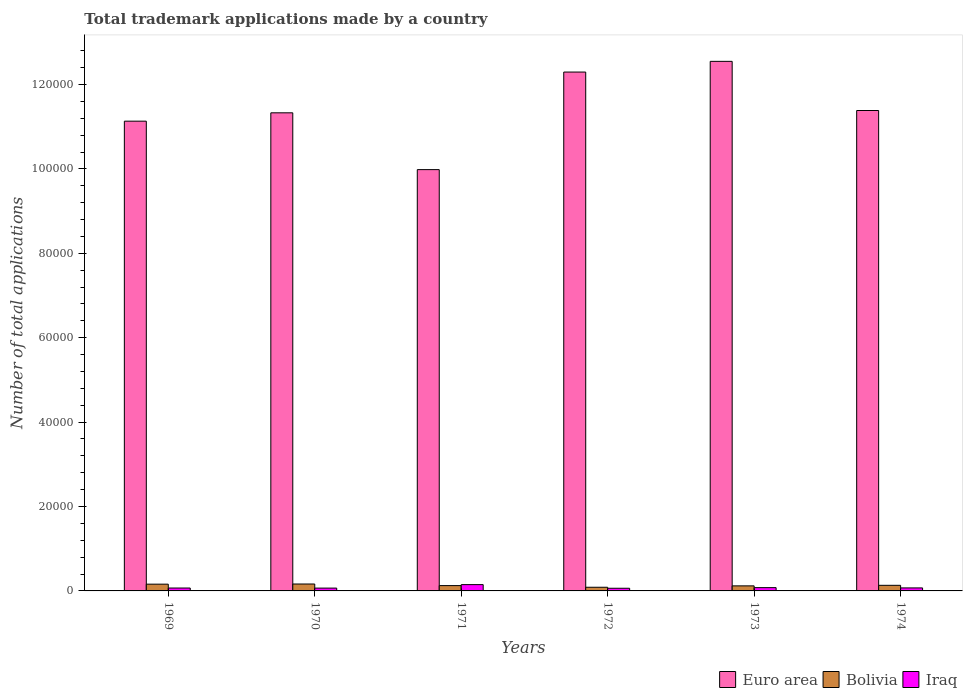How many bars are there on the 4th tick from the right?
Give a very brief answer. 3. What is the label of the 1st group of bars from the left?
Ensure brevity in your answer.  1969. What is the number of applications made by in Iraq in 1969?
Ensure brevity in your answer.  688. Across all years, what is the maximum number of applications made by in Bolivia?
Ensure brevity in your answer.  1640. Across all years, what is the minimum number of applications made by in Bolivia?
Your answer should be compact. 868. In which year was the number of applications made by in Euro area maximum?
Keep it short and to the point. 1973. What is the total number of applications made by in Iraq in the graph?
Provide a short and direct response. 4972. What is the difference between the number of applications made by in Iraq in 1972 and that in 1974?
Offer a very short reply. -84. What is the difference between the number of applications made by in Iraq in 1969 and the number of applications made by in Bolivia in 1973?
Give a very brief answer. -509. What is the average number of applications made by in Iraq per year?
Your answer should be compact. 828.67. In the year 1972, what is the difference between the number of applications made by in Euro area and number of applications made by in Bolivia?
Provide a short and direct response. 1.22e+05. What is the ratio of the number of applications made by in Bolivia in 1969 to that in 1973?
Offer a very short reply. 1.34. Is the number of applications made by in Bolivia in 1970 less than that in 1972?
Provide a succinct answer. No. Is the difference between the number of applications made by in Euro area in 1969 and 1974 greater than the difference between the number of applications made by in Bolivia in 1969 and 1974?
Make the answer very short. No. What is the difference between the highest and the second highest number of applications made by in Iraq?
Your answer should be very brief. 715. What is the difference between the highest and the lowest number of applications made by in Iraq?
Your answer should be very brief. 863. Is the sum of the number of applications made by in Bolivia in 1973 and 1974 greater than the maximum number of applications made by in Euro area across all years?
Your response must be concise. No. What does the 3rd bar from the left in 1970 represents?
Keep it short and to the point. Iraq. Are all the bars in the graph horizontal?
Provide a short and direct response. No. How many years are there in the graph?
Your answer should be very brief. 6. Are the values on the major ticks of Y-axis written in scientific E-notation?
Provide a short and direct response. No. Does the graph contain any zero values?
Provide a succinct answer. No. Where does the legend appear in the graph?
Provide a succinct answer. Bottom right. What is the title of the graph?
Give a very brief answer. Total trademark applications made by a country. Does "Croatia" appear as one of the legend labels in the graph?
Provide a short and direct response. No. What is the label or title of the X-axis?
Give a very brief answer. Years. What is the label or title of the Y-axis?
Make the answer very short. Number of total applications. What is the Number of total applications of Euro area in 1969?
Your answer should be very brief. 1.11e+05. What is the Number of total applications of Bolivia in 1969?
Provide a short and direct response. 1600. What is the Number of total applications in Iraq in 1969?
Your response must be concise. 688. What is the Number of total applications of Euro area in 1970?
Give a very brief answer. 1.13e+05. What is the Number of total applications in Bolivia in 1970?
Offer a very short reply. 1640. What is the Number of total applications in Iraq in 1970?
Offer a very short reply. 669. What is the Number of total applications of Euro area in 1971?
Your response must be concise. 9.98e+04. What is the Number of total applications of Bolivia in 1971?
Make the answer very short. 1261. What is the Number of total applications in Iraq in 1971?
Your answer should be very brief. 1493. What is the Number of total applications in Euro area in 1972?
Your answer should be very brief. 1.23e+05. What is the Number of total applications in Bolivia in 1972?
Ensure brevity in your answer.  868. What is the Number of total applications of Iraq in 1972?
Offer a terse response. 630. What is the Number of total applications in Euro area in 1973?
Give a very brief answer. 1.25e+05. What is the Number of total applications of Bolivia in 1973?
Your response must be concise. 1197. What is the Number of total applications of Iraq in 1973?
Give a very brief answer. 778. What is the Number of total applications in Euro area in 1974?
Keep it short and to the point. 1.14e+05. What is the Number of total applications in Bolivia in 1974?
Make the answer very short. 1327. What is the Number of total applications in Iraq in 1974?
Make the answer very short. 714. Across all years, what is the maximum Number of total applications in Euro area?
Give a very brief answer. 1.25e+05. Across all years, what is the maximum Number of total applications in Bolivia?
Provide a short and direct response. 1640. Across all years, what is the maximum Number of total applications in Iraq?
Your response must be concise. 1493. Across all years, what is the minimum Number of total applications in Euro area?
Your answer should be compact. 9.98e+04. Across all years, what is the minimum Number of total applications of Bolivia?
Provide a succinct answer. 868. Across all years, what is the minimum Number of total applications of Iraq?
Offer a very short reply. 630. What is the total Number of total applications in Euro area in the graph?
Offer a terse response. 6.87e+05. What is the total Number of total applications in Bolivia in the graph?
Keep it short and to the point. 7893. What is the total Number of total applications in Iraq in the graph?
Provide a short and direct response. 4972. What is the difference between the Number of total applications in Euro area in 1969 and that in 1970?
Give a very brief answer. -1977. What is the difference between the Number of total applications of Bolivia in 1969 and that in 1970?
Provide a succinct answer. -40. What is the difference between the Number of total applications in Euro area in 1969 and that in 1971?
Provide a short and direct response. 1.15e+04. What is the difference between the Number of total applications of Bolivia in 1969 and that in 1971?
Offer a very short reply. 339. What is the difference between the Number of total applications of Iraq in 1969 and that in 1971?
Make the answer very short. -805. What is the difference between the Number of total applications in Euro area in 1969 and that in 1972?
Give a very brief answer. -1.16e+04. What is the difference between the Number of total applications of Bolivia in 1969 and that in 1972?
Provide a short and direct response. 732. What is the difference between the Number of total applications of Euro area in 1969 and that in 1973?
Make the answer very short. -1.42e+04. What is the difference between the Number of total applications in Bolivia in 1969 and that in 1973?
Keep it short and to the point. 403. What is the difference between the Number of total applications of Iraq in 1969 and that in 1973?
Your answer should be very brief. -90. What is the difference between the Number of total applications of Euro area in 1969 and that in 1974?
Offer a very short reply. -2525. What is the difference between the Number of total applications in Bolivia in 1969 and that in 1974?
Give a very brief answer. 273. What is the difference between the Number of total applications of Euro area in 1970 and that in 1971?
Offer a very short reply. 1.35e+04. What is the difference between the Number of total applications of Bolivia in 1970 and that in 1971?
Make the answer very short. 379. What is the difference between the Number of total applications of Iraq in 1970 and that in 1971?
Your answer should be compact. -824. What is the difference between the Number of total applications of Euro area in 1970 and that in 1972?
Your answer should be very brief. -9657. What is the difference between the Number of total applications in Bolivia in 1970 and that in 1972?
Provide a succinct answer. 772. What is the difference between the Number of total applications in Iraq in 1970 and that in 1972?
Offer a terse response. 39. What is the difference between the Number of total applications in Euro area in 1970 and that in 1973?
Give a very brief answer. -1.22e+04. What is the difference between the Number of total applications of Bolivia in 1970 and that in 1973?
Offer a very short reply. 443. What is the difference between the Number of total applications of Iraq in 1970 and that in 1973?
Ensure brevity in your answer.  -109. What is the difference between the Number of total applications in Euro area in 1970 and that in 1974?
Your response must be concise. -548. What is the difference between the Number of total applications of Bolivia in 1970 and that in 1974?
Offer a very short reply. 313. What is the difference between the Number of total applications of Iraq in 1970 and that in 1974?
Your response must be concise. -45. What is the difference between the Number of total applications of Euro area in 1971 and that in 1972?
Your answer should be very brief. -2.31e+04. What is the difference between the Number of total applications of Bolivia in 1971 and that in 1972?
Your answer should be very brief. 393. What is the difference between the Number of total applications of Iraq in 1971 and that in 1972?
Provide a short and direct response. 863. What is the difference between the Number of total applications of Euro area in 1971 and that in 1973?
Offer a terse response. -2.57e+04. What is the difference between the Number of total applications in Bolivia in 1971 and that in 1973?
Offer a terse response. 64. What is the difference between the Number of total applications in Iraq in 1971 and that in 1973?
Provide a short and direct response. 715. What is the difference between the Number of total applications in Euro area in 1971 and that in 1974?
Offer a very short reply. -1.40e+04. What is the difference between the Number of total applications of Bolivia in 1971 and that in 1974?
Give a very brief answer. -66. What is the difference between the Number of total applications of Iraq in 1971 and that in 1974?
Your response must be concise. 779. What is the difference between the Number of total applications in Euro area in 1972 and that in 1973?
Your answer should be compact. -2537. What is the difference between the Number of total applications in Bolivia in 1972 and that in 1973?
Provide a succinct answer. -329. What is the difference between the Number of total applications in Iraq in 1972 and that in 1973?
Your answer should be compact. -148. What is the difference between the Number of total applications of Euro area in 1972 and that in 1974?
Keep it short and to the point. 9109. What is the difference between the Number of total applications in Bolivia in 1972 and that in 1974?
Provide a short and direct response. -459. What is the difference between the Number of total applications of Iraq in 1972 and that in 1974?
Provide a short and direct response. -84. What is the difference between the Number of total applications in Euro area in 1973 and that in 1974?
Offer a terse response. 1.16e+04. What is the difference between the Number of total applications of Bolivia in 1973 and that in 1974?
Offer a terse response. -130. What is the difference between the Number of total applications of Euro area in 1969 and the Number of total applications of Bolivia in 1970?
Keep it short and to the point. 1.10e+05. What is the difference between the Number of total applications in Euro area in 1969 and the Number of total applications in Iraq in 1970?
Your answer should be compact. 1.11e+05. What is the difference between the Number of total applications in Bolivia in 1969 and the Number of total applications in Iraq in 1970?
Provide a succinct answer. 931. What is the difference between the Number of total applications of Euro area in 1969 and the Number of total applications of Bolivia in 1971?
Offer a very short reply. 1.10e+05. What is the difference between the Number of total applications in Euro area in 1969 and the Number of total applications in Iraq in 1971?
Offer a terse response. 1.10e+05. What is the difference between the Number of total applications in Bolivia in 1969 and the Number of total applications in Iraq in 1971?
Provide a short and direct response. 107. What is the difference between the Number of total applications in Euro area in 1969 and the Number of total applications in Bolivia in 1972?
Give a very brief answer. 1.10e+05. What is the difference between the Number of total applications in Euro area in 1969 and the Number of total applications in Iraq in 1972?
Offer a terse response. 1.11e+05. What is the difference between the Number of total applications in Bolivia in 1969 and the Number of total applications in Iraq in 1972?
Your response must be concise. 970. What is the difference between the Number of total applications of Euro area in 1969 and the Number of total applications of Bolivia in 1973?
Your answer should be compact. 1.10e+05. What is the difference between the Number of total applications of Euro area in 1969 and the Number of total applications of Iraq in 1973?
Provide a succinct answer. 1.11e+05. What is the difference between the Number of total applications in Bolivia in 1969 and the Number of total applications in Iraq in 1973?
Ensure brevity in your answer.  822. What is the difference between the Number of total applications of Euro area in 1969 and the Number of total applications of Bolivia in 1974?
Make the answer very short. 1.10e+05. What is the difference between the Number of total applications of Euro area in 1969 and the Number of total applications of Iraq in 1974?
Provide a succinct answer. 1.11e+05. What is the difference between the Number of total applications in Bolivia in 1969 and the Number of total applications in Iraq in 1974?
Keep it short and to the point. 886. What is the difference between the Number of total applications of Euro area in 1970 and the Number of total applications of Bolivia in 1971?
Provide a succinct answer. 1.12e+05. What is the difference between the Number of total applications in Euro area in 1970 and the Number of total applications in Iraq in 1971?
Make the answer very short. 1.12e+05. What is the difference between the Number of total applications in Bolivia in 1970 and the Number of total applications in Iraq in 1971?
Your answer should be very brief. 147. What is the difference between the Number of total applications in Euro area in 1970 and the Number of total applications in Bolivia in 1972?
Provide a succinct answer. 1.12e+05. What is the difference between the Number of total applications of Euro area in 1970 and the Number of total applications of Iraq in 1972?
Your answer should be very brief. 1.13e+05. What is the difference between the Number of total applications of Bolivia in 1970 and the Number of total applications of Iraq in 1972?
Your answer should be compact. 1010. What is the difference between the Number of total applications in Euro area in 1970 and the Number of total applications in Bolivia in 1973?
Your answer should be very brief. 1.12e+05. What is the difference between the Number of total applications in Euro area in 1970 and the Number of total applications in Iraq in 1973?
Ensure brevity in your answer.  1.13e+05. What is the difference between the Number of total applications of Bolivia in 1970 and the Number of total applications of Iraq in 1973?
Offer a terse response. 862. What is the difference between the Number of total applications in Euro area in 1970 and the Number of total applications in Bolivia in 1974?
Provide a short and direct response. 1.12e+05. What is the difference between the Number of total applications in Euro area in 1970 and the Number of total applications in Iraq in 1974?
Offer a very short reply. 1.13e+05. What is the difference between the Number of total applications in Bolivia in 1970 and the Number of total applications in Iraq in 1974?
Provide a short and direct response. 926. What is the difference between the Number of total applications in Euro area in 1971 and the Number of total applications in Bolivia in 1972?
Provide a short and direct response. 9.90e+04. What is the difference between the Number of total applications in Euro area in 1971 and the Number of total applications in Iraq in 1972?
Provide a short and direct response. 9.92e+04. What is the difference between the Number of total applications of Bolivia in 1971 and the Number of total applications of Iraq in 1972?
Your answer should be compact. 631. What is the difference between the Number of total applications of Euro area in 1971 and the Number of total applications of Bolivia in 1973?
Offer a very short reply. 9.86e+04. What is the difference between the Number of total applications of Euro area in 1971 and the Number of total applications of Iraq in 1973?
Your answer should be very brief. 9.91e+04. What is the difference between the Number of total applications of Bolivia in 1971 and the Number of total applications of Iraq in 1973?
Offer a terse response. 483. What is the difference between the Number of total applications of Euro area in 1971 and the Number of total applications of Bolivia in 1974?
Offer a very short reply. 9.85e+04. What is the difference between the Number of total applications in Euro area in 1971 and the Number of total applications in Iraq in 1974?
Give a very brief answer. 9.91e+04. What is the difference between the Number of total applications of Bolivia in 1971 and the Number of total applications of Iraq in 1974?
Make the answer very short. 547. What is the difference between the Number of total applications in Euro area in 1972 and the Number of total applications in Bolivia in 1973?
Your answer should be very brief. 1.22e+05. What is the difference between the Number of total applications in Euro area in 1972 and the Number of total applications in Iraq in 1973?
Your answer should be compact. 1.22e+05. What is the difference between the Number of total applications in Euro area in 1972 and the Number of total applications in Bolivia in 1974?
Make the answer very short. 1.22e+05. What is the difference between the Number of total applications of Euro area in 1972 and the Number of total applications of Iraq in 1974?
Keep it short and to the point. 1.22e+05. What is the difference between the Number of total applications in Bolivia in 1972 and the Number of total applications in Iraq in 1974?
Give a very brief answer. 154. What is the difference between the Number of total applications in Euro area in 1973 and the Number of total applications in Bolivia in 1974?
Provide a succinct answer. 1.24e+05. What is the difference between the Number of total applications in Euro area in 1973 and the Number of total applications in Iraq in 1974?
Provide a short and direct response. 1.25e+05. What is the difference between the Number of total applications of Bolivia in 1973 and the Number of total applications of Iraq in 1974?
Offer a very short reply. 483. What is the average Number of total applications in Euro area per year?
Your answer should be compact. 1.14e+05. What is the average Number of total applications in Bolivia per year?
Your answer should be compact. 1315.5. What is the average Number of total applications of Iraq per year?
Provide a succinct answer. 828.67. In the year 1969, what is the difference between the Number of total applications in Euro area and Number of total applications in Bolivia?
Provide a short and direct response. 1.10e+05. In the year 1969, what is the difference between the Number of total applications of Euro area and Number of total applications of Iraq?
Make the answer very short. 1.11e+05. In the year 1969, what is the difference between the Number of total applications in Bolivia and Number of total applications in Iraq?
Make the answer very short. 912. In the year 1970, what is the difference between the Number of total applications of Euro area and Number of total applications of Bolivia?
Ensure brevity in your answer.  1.12e+05. In the year 1970, what is the difference between the Number of total applications in Euro area and Number of total applications in Iraq?
Your answer should be very brief. 1.13e+05. In the year 1970, what is the difference between the Number of total applications in Bolivia and Number of total applications in Iraq?
Give a very brief answer. 971. In the year 1971, what is the difference between the Number of total applications of Euro area and Number of total applications of Bolivia?
Provide a short and direct response. 9.86e+04. In the year 1971, what is the difference between the Number of total applications in Euro area and Number of total applications in Iraq?
Your response must be concise. 9.83e+04. In the year 1971, what is the difference between the Number of total applications of Bolivia and Number of total applications of Iraq?
Provide a succinct answer. -232. In the year 1972, what is the difference between the Number of total applications of Euro area and Number of total applications of Bolivia?
Offer a terse response. 1.22e+05. In the year 1972, what is the difference between the Number of total applications of Euro area and Number of total applications of Iraq?
Ensure brevity in your answer.  1.22e+05. In the year 1972, what is the difference between the Number of total applications of Bolivia and Number of total applications of Iraq?
Your answer should be very brief. 238. In the year 1973, what is the difference between the Number of total applications in Euro area and Number of total applications in Bolivia?
Your answer should be very brief. 1.24e+05. In the year 1973, what is the difference between the Number of total applications in Euro area and Number of total applications in Iraq?
Ensure brevity in your answer.  1.25e+05. In the year 1973, what is the difference between the Number of total applications in Bolivia and Number of total applications in Iraq?
Offer a terse response. 419. In the year 1974, what is the difference between the Number of total applications in Euro area and Number of total applications in Bolivia?
Offer a terse response. 1.13e+05. In the year 1974, what is the difference between the Number of total applications in Euro area and Number of total applications in Iraq?
Your answer should be compact. 1.13e+05. In the year 1974, what is the difference between the Number of total applications in Bolivia and Number of total applications in Iraq?
Your answer should be compact. 613. What is the ratio of the Number of total applications in Euro area in 1969 to that in 1970?
Offer a very short reply. 0.98. What is the ratio of the Number of total applications of Bolivia in 1969 to that in 1970?
Your response must be concise. 0.98. What is the ratio of the Number of total applications in Iraq in 1969 to that in 1970?
Ensure brevity in your answer.  1.03. What is the ratio of the Number of total applications in Euro area in 1969 to that in 1971?
Keep it short and to the point. 1.11. What is the ratio of the Number of total applications in Bolivia in 1969 to that in 1971?
Your answer should be very brief. 1.27. What is the ratio of the Number of total applications of Iraq in 1969 to that in 1971?
Offer a very short reply. 0.46. What is the ratio of the Number of total applications of Euro area in 1969 to that in 1972?
Provide a succinct answer. 0.91. What is the ratio of the Number of total applications in Bolivia in 1969 to that in 1972?
Give a very brief answer. 1.84. What is the ratio of the Number of total applications in Iraq in 1969 to that in 1972?
Provide a succinct answer. 1.09. What is the ratio of the Number of total applications in Euro area in 1969 to that in 1973?
Provide a short and direct response. 0.89. What is the ratio of the Number of total applications of Bolivia in 1969 to that in 1973?
Your answer should be compact. 1.34. What is the ratio of the Number of total applications of Iraq in 1969 to that in 1973?
Give a very brief answer. 0.88. What is the ratio of the Number of total applications of Euro area in 1969 to that in 1974?
Ensure brevity in your answer.  0.98. What is the ratio of the Number of total applications in Bolivia in 1969 to that in 1974?
Provide a short and direct response. 1.21. What is the ratio of the Number of total applications in Iraq in 1969 to that in 1974?
Make the answer very short. 0.96. What is the ratio of the Number of total applications of Euro area in 1970 to that in 1971?
Your answer should be compact. 1.13. What is the ratio of the Number of total applications of Bolivia in 1970 to that in 1971?
Your answer should be very brief. 1.3. What is the ratio of the Number of total applications of Iraq in 1970 to that in 1971?
Ensure brevity in your answer.  0.45. What is the ratio of the Number of total applications in Euro area in 1970 to that in 1972?
Your response must be concise. 0.92. What is the ratio of the Number of total applications in Bolivia in 1970 to that in 1972?
Your answer should be compact. 1.89. What is the ratio of the Number of total applications in Iraq in 1970 to that in 1972?
Provide a succinct answer. 1.06. What is the ratio of the Number of total applications of Euro area in 1970 to that in 1973?
Provide a short and direct response. 0.9. What is the ratio of the Number of total applications in Bolivia in 1970 to that in 1973?
Ensure brevity in your answer.  1.37. What is the ratio of the Number of total applications of Iraq in 1970 to that in 1973?
Give a very brief answer. 0.86. What is the ratio of the Number of total applications of Bolivia in 1970 to that in 1974?
Your answer should be very brief. 1.24. What is the ratio of the Number of total applications of Iraq in 1970 to that in 1974?
Give a very brief answer. 0.94. What is the ratio of the Number of total applications in Euro area in 1971 to that in 1972?
Your answer should be very brief. 0.81. What is the ratio of the Number of total applications in Bolivia in 1971 to that in 1972?
Keep it short and to the point. 1.45. What is the ratio of the Number of total applications in Iraq in 1971 to that in 1972?
Give a very brief answer. 2.37. What is the ratio of the Number of total applications of Euro area in 1971 to that in 1973?
Ensure brevity in your answer.  0.8. What is the ratio of the Number of total applications in Bolivia in 1971 to that in 1973?
Ensure brevity in your answer.  1.05. What is the ratio of the Number of total applications of Iraq in 1971 to that in 1973?
Provide a succinct answer. 1.92. What is the ratio of the Number of total applications in Euro area in 1971 to that in 1974?
Provide a short and direct response. 0.88. What is the ratio of the Number of total applications in Bolivia in 1971 to that in 1974?
Offer a terse response. 0.95. What is the ratio of the Number of total applications in Iraq in 1971 to that in 1974?
Provide a succinct answer. 2.09. What is the ratio of the Number of total applications of Euro area in 1972 to that in 1973?
Keep it short and to the point. 0.98. What is the ratio of the Number of total applications of Bolivia in 1972 to that in 1973?
Offer a terse response. 0.73. What is the ratio of the Number of total applications in Iraq in 1972 to that in 1973?
Your answer should be very brief. 0.81. What is the ratio of the Number of total applications in Bolivia in 1972 to that in 1974?
Provide a short and direct response. 0.65. What is the ratio of the Number of total applications in Iraq in 1972 to that in 1974?
Offer a very short reply. 0.88. What is the ratio of the Number of total applications of Euro area in 1973 to that in 1974?
Make the answer very short. 1.1. What is the ratio of the Number of total applications of Bolivia in 1973 to that in 1974?
Your answer should be very brief. 0.9. What is the ratio of the Number of total applications of Iraq in 1973 to that in 1974?
Ensure brevity in your answer.  1.09. What is the difference between the highest and the second highest Number of total applications in Euro area?
Ensure brevity in your answer.  2537. What is the difference between the highest and the second highest Number of total applications in Bolivia?
Provide a short and direct response. 40. What is the difference between the highest and the second highest Number of total applications in Iraq?
Your answer should be compact. 715. What is the difference between the highest and the lowest Number of total applications of Euro area?
Offer a terse response. 2.57e+04. What is the difference between the highest and the lowest Number of total applications in Bolivia?
Provide a short and direct response. 772. What is the difference between the highest and the lowest Number of total applications in Iraq?
Your response must be concise. 863. 